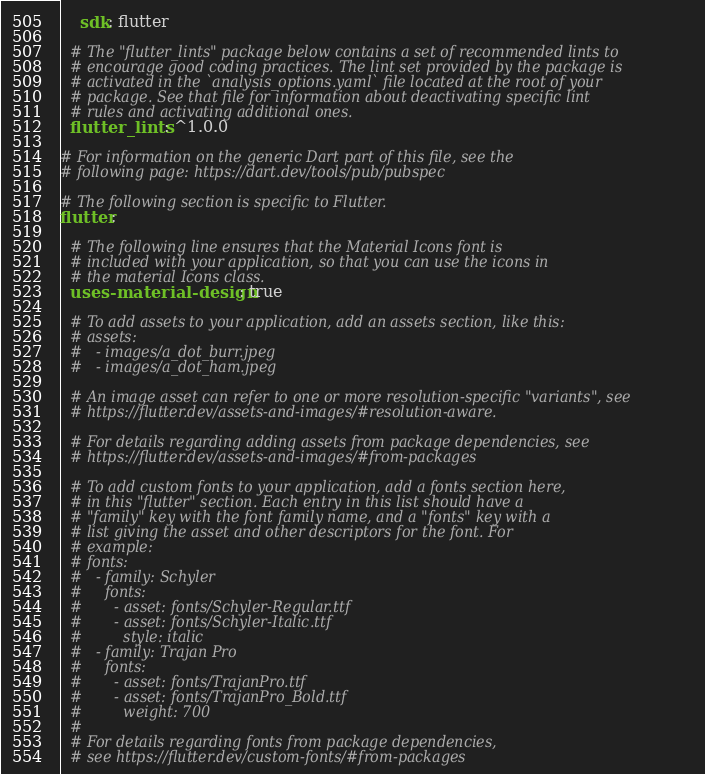<code> <loc_0><loc_0><loc_500><loc_500><_YAML_>    sdk: flutter

  # The "flutter_lints" package below contains a set of recommended lints to
  # encourage good coding practices. The lint set provided by the package is
  # activated in the `analysis_options.yaml` file located at the root of your
  # package. See that file for information about deactivating specific lint
  # rules and activating additional ones.
  flutter_lints: ^1.0.0

# For information on the generic Dart part of this file, see the
# following page: https://dart.dev/tools/pub/pubspec

# The following section is specific to Flutter.
flutter:

  # The following line ensures that the Material Icons font is
  # included with your application, so that you can use the icons in
  # the material Icons class.
  uses-material-design: true

  # To add assets to your application, add an assets section, like this:
  # assets:
  #   - images/a_dot_burr.jpeg
  #   - images/a_dot_ham.jpeg

  # An image asset can refer to one or more resolution-specific "variants", see
  # https://flutter.dev/assets-and-images/#resolution-aware.

  # For details regarding adding assets from package dependencies, see
  # https://flutter.dev/assets-and-images/#from-packages

  # To add custom fonts to your application, add a fonts section here,
  # in this "flutter" section. Each entry in this list should have a
  # "family" key with the font family name, and a "fonts" key with a
  # list giving the asset and other descriptors for the font. For
  # example:
  # fonts:
  #   - family: Schyler
  #     fonts:
  #       - asset: fonts/Schyler-Regular.ttf
  #       - asset: fonts/Schyler-Italic.ttf
  #         style: italic
  #   - family: Trajan Pro
  #     fonts:
  #       - asset: fonts/TrajanPro.ttf
  #       - asset: fonts/TrajanPro_Bold.ttf
  #         weight: 700
  #
  # For details regarding fonts from package dependencies,
  # see https://flutter.dev/custom-fonts/#from-packages
</code> 